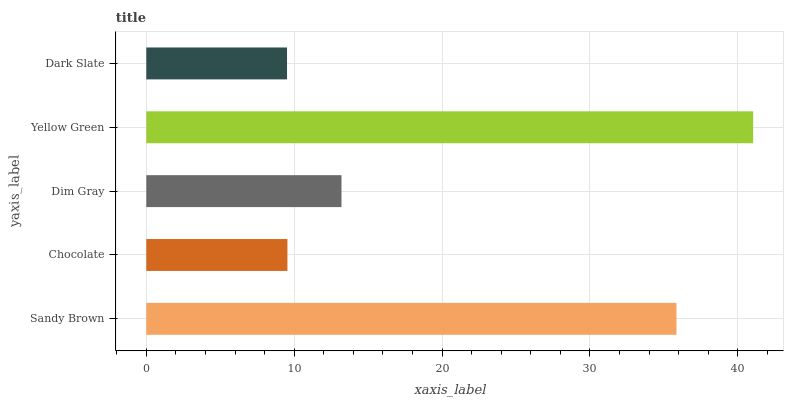Is Dark Slate the minimum?
Answer yes or no. Yes. Is Yellow Green the maximum?
Answer yes or no. Yes. Is Chocolate the minimum?
Answer yes or no. No. Is Chocolate the maximum?
Answer yes or no. No. Is Sandy Brown greater than Chocolate?
Answer yes or no. Yes. Is Chocolate less than Sandy Brown?
Answer yes or no. Yes. Is Chocolate greater than Sandy Brown?
Answer yes or no. No. Is Sandy Brown less than Chocolate?
Answer yes or no. No. Is Dim Gray the high median?
Answer yes or no. Yes. Is Dim Gray the low median?
Answer yes or no. Yes. Is Yellow Green the high median?
Answer yes or no. No. Is Dark Slate the low median?
Answer yes or no. No. 